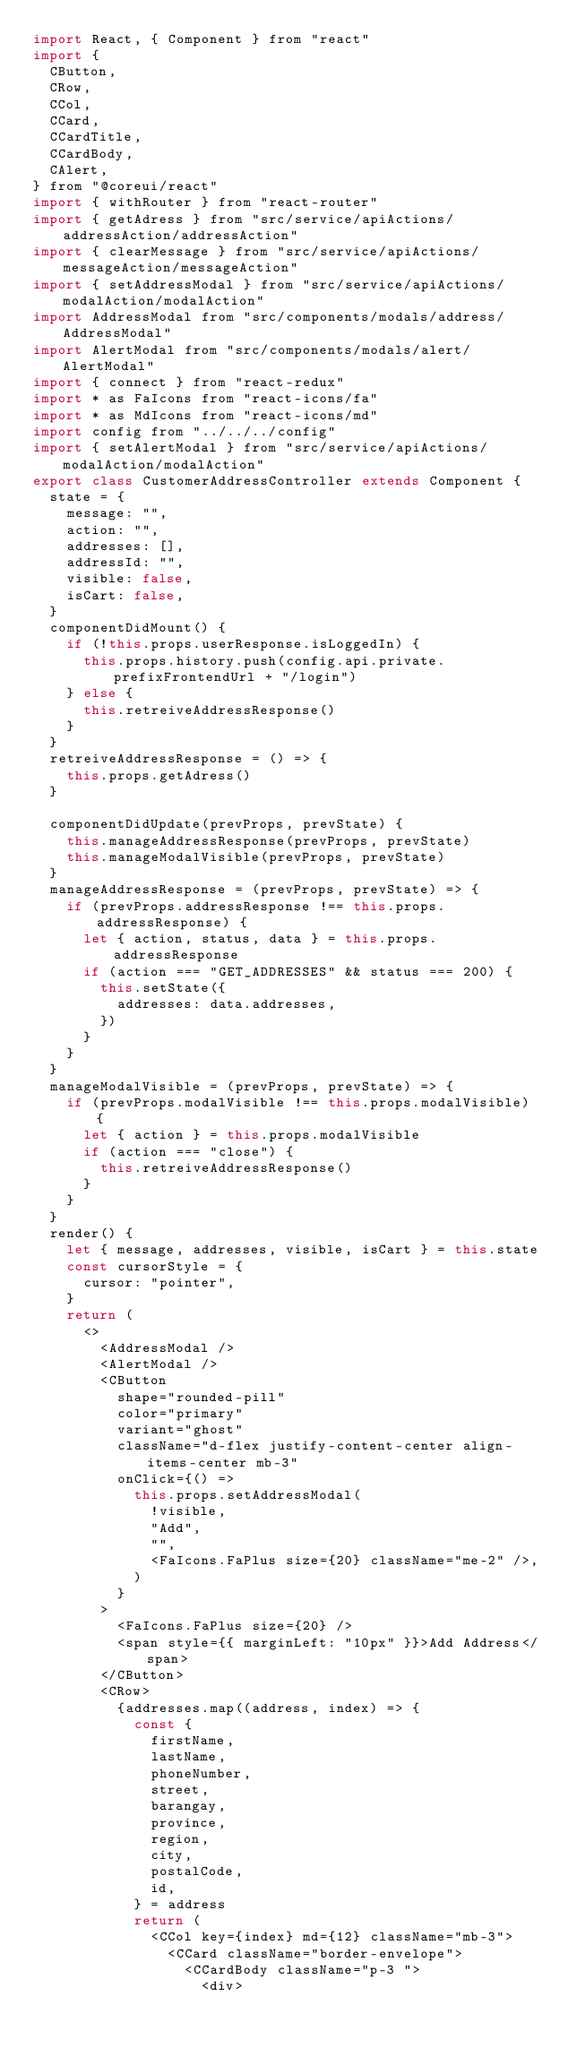Convert code to text. <code><loc_0><loc_0><loc_500><loc_500><_JavaScript_>import React, { Component } from "react"
import {
  CButton,
  CRow,
  CCol,
  CCard,
  CCardTitle,
  CCardBody,
  CAlert,
} from "@coreui/react"
import { withRouter } from "react-router"
import { getAdress } from "src/service/apiActions/addressAction/addressAction"
import { clearMessage } from "src/service/apiActions/messageAction/messageAction"
import { setAddressModal } from "src/service/apiActions/modalAction/modalAction"
import AddressModal from "src/components/modals/address/AddressModal"
import AlertModal from "src/components/modals/alert/AlertModal"
import { connect } from "react-redux"
import * as FaIcons from "react-icons/fa"
import * as MdIcons from "react-icons/md"
import config from "../../../config"
import { setAlertModal } from "src/service/apiActions/modalAction/modalAction"
export class CustomerAddressController extends Component {
  state = {
    message: "",
    action: "",
    addresses: [],
    addressId: "",
    visible: false,
    isCart: false,
  }
  componentDidMount() {
    if (!this.props.userResponse.isLoggedIn) {
      this.props.history.push(config.api.private.prefixFrontendUrl + "/login")
    } else {
      this.retreiveAddressResponse()
    }
  }
  retreiveAddressResponse = () => {
    this.props.getAdress()
  }

  componentDidUpdate(prevProps, prevState) {
    this.manageAddressResponse(prevProps, prevState)
    this.manageModalVisible(prevProps, prevState)
  }
  manageAddressResponse = (prevProps, prevState) => {
    if (prevProps.addressResponse !== this.props.addressResponse) {
      let { action, status, data } = this.props.addressResponse
      if (action === "GET_ADDRESSES" && status === 200) {
        this.setState({
          addresses: data.addresses,
        })
      }
    }
  }
  manageModalVisible = (prevProps, prevState) => {
    if (prevProps.modalVisible !== this.props.modalVisible) {
      let { action } = this.props.modalVisible
      if (action === "close") {
        this.retreiveAddressResponse()
      }
    }
  }
  render() {
    let { message, addresses, visible, isCart } = this.state
    const cursorStyle = {
      cursor: "pointer",
    }
    return (
      <>
        <AddressModal />
        <AlertModal />
        <CButton
          shape="rounded-pill"
          color="primary"
          variant="ghost"
          className="d-flex justify-content-center align-items-center mb-3"
          onClick={() =>
            this.props.setAddressModal(
              !visible,
              "Add",
              "",
              <FaIcons.FaPlus size={20} className="me-2" />,
            )
          }
        >
          <FaIcons.FaPlus size={20} />
          <span style={{ marginLeft: "10px" }}>Add Address</span>
        </CButton>
        <CRow>
          {addresses.map((address, index) => {
            const {
              firstName,
              lastName,
              phoneNumber,
              street,
              barangay,
              province,
              region,
              city,
              postalCode,
              id,
            } = address
            return (
              <CCol key={index} md={12} className="mb-3">
                <CCard className="border-envelope">
                  <CCardBody className="p-3 ">
                    <div></code> 